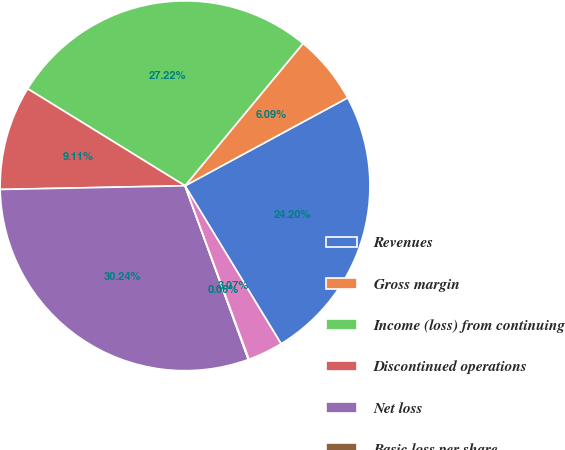<chart> <loc_0><loc_0><loc_500><loc_500><pie_chart><fcel>Revenues<fcel>Gross margin<fcel>Income (loss) from continuing<fcel>Discontinued operations<fcel>Net loss<fcel>Basic loss per share<fcel>Diluted loss per share<nl><fcel>24.2%<fcel>6.09%<fcel>27.22%<fcel>9.11%<fcel>30.24%<fcel>0.06%<fcel>3.07%<nl></chart> 